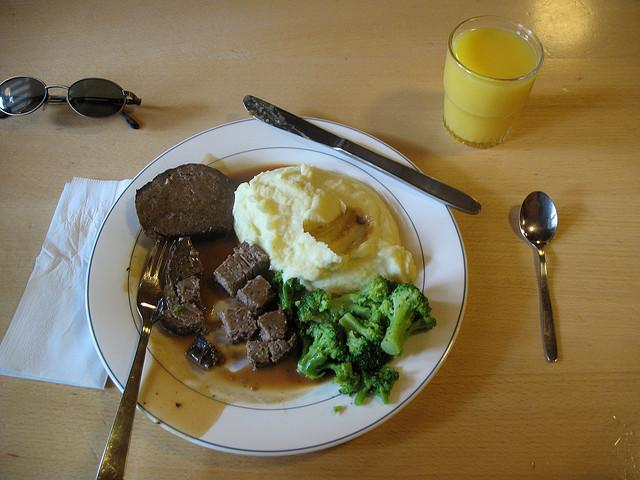Which food on the plate is highest carbohydrates?

Choices:
A) beef
B) gravy
C) potatoes
D) broccoli potatoes 